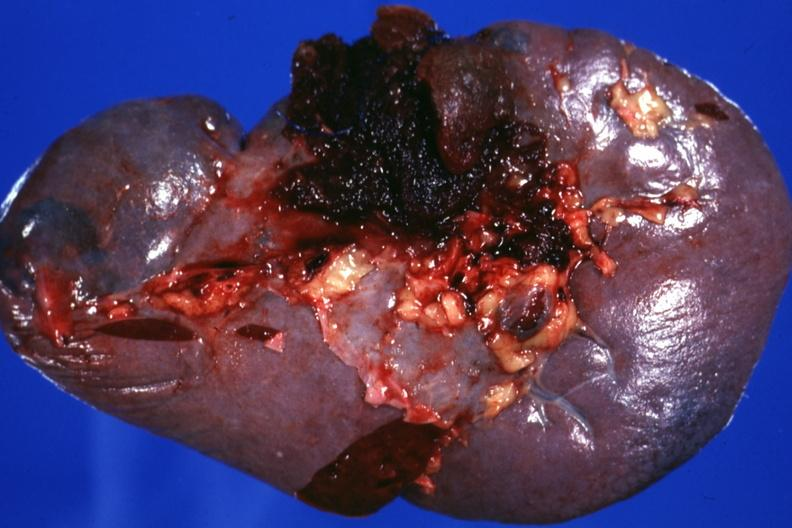s cervix duplication present?
Answer the question using a single word or phrase. No 